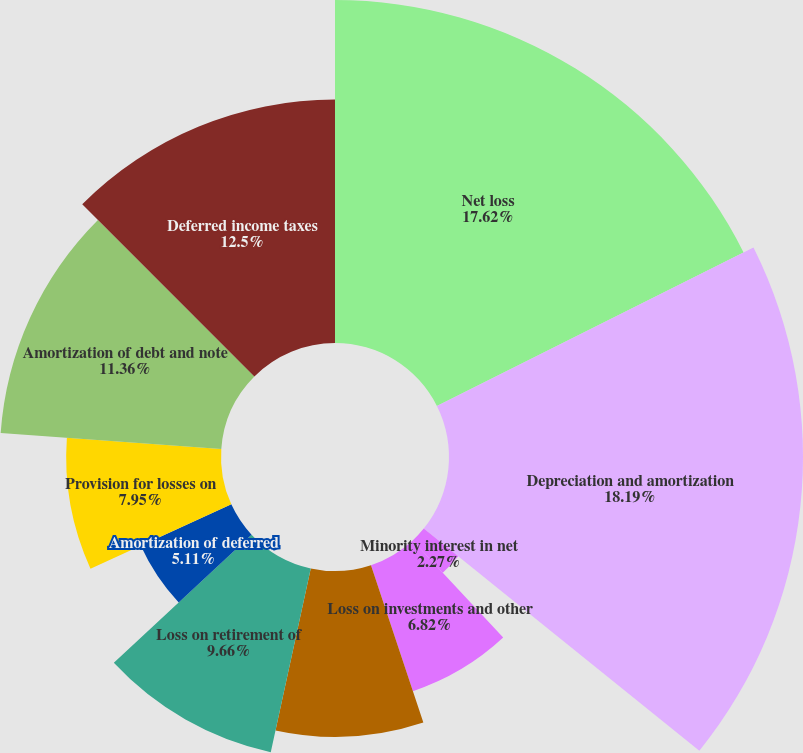Convert chart. <chart><loc_0><loc_0><loc_500><loc_500><pie_chart><fcel>Net loss<fcel>Depreciation and amortization<fcel>Minority interest in net<fcel>Loss on investments and other<fcel>Impairments net loss on sale<fcel>Loss on retirement of<fcel>Amortization of deferred<fcel>Provision for losses on<fcel>Amortization of debt and note<fcel>Deferred income taxes<nl><fcel>17.61%<fcel>18.18%<fcel>2.27%<fcel>6.82%<fcel>8.52%<fcel>9.66%<fcel>5.11%<fcel>7.95%<fcel>11.36%<fcel>12.5%<nl></chart> 